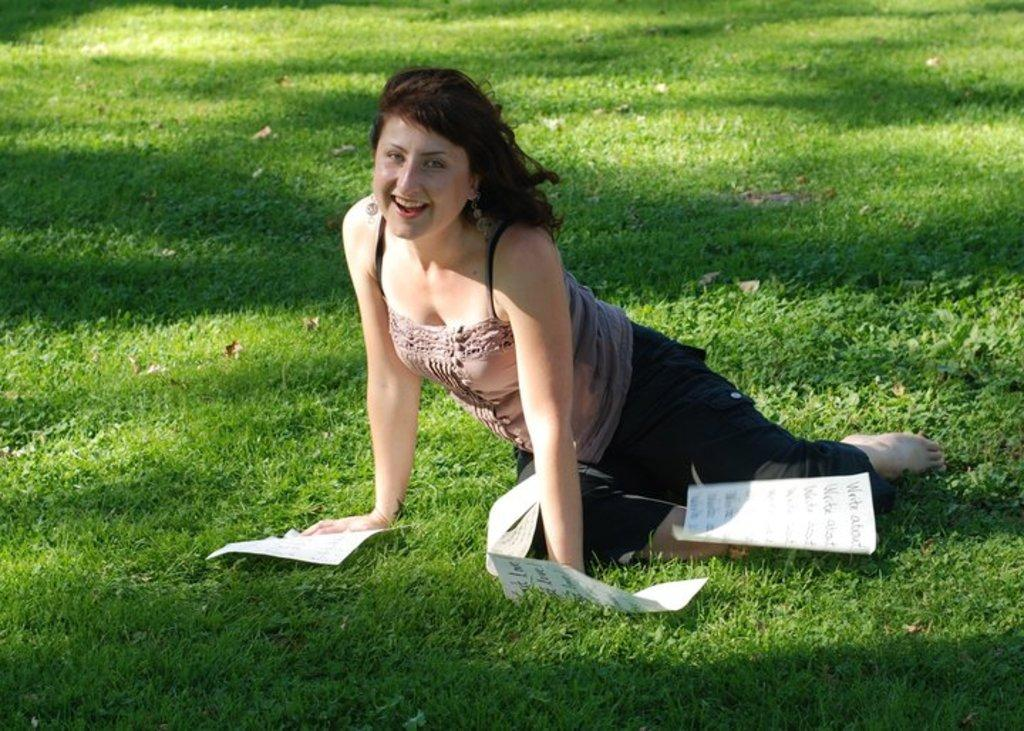Who is present in the image? There is a woman in the image. What is the woman's facial expression? The woman is smiling. Where is the woman located in the image? The woman is sitting on the ground. ground. What objects can be seen in the image? There are papers in the image. What type of natural environment is visible in the woman in? There is grass in the image. What type of grape is the woman holding in the image? There is no grape present in the image. How does the woman's eye contribute to the overall mood of the image? The woman's eye is not mentioned in the image, so it cannot contribute to the overall mood. 